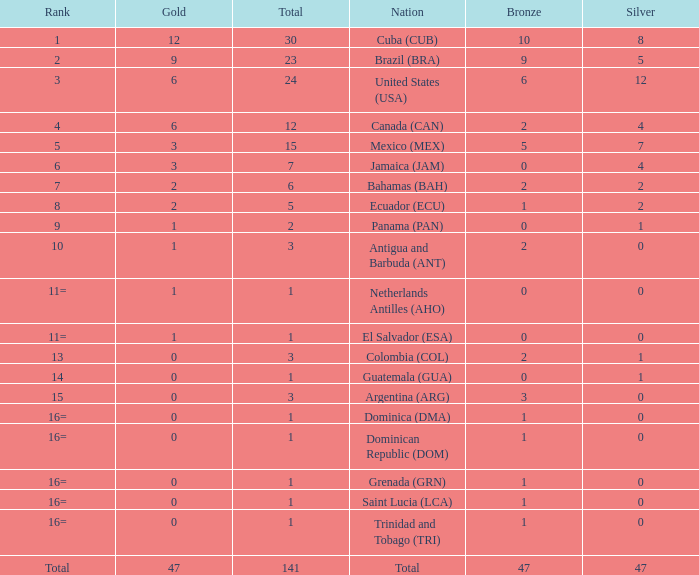How many bronzes have a Nation of jamaica (jam), and a Total smaller than 7? 0.0. 